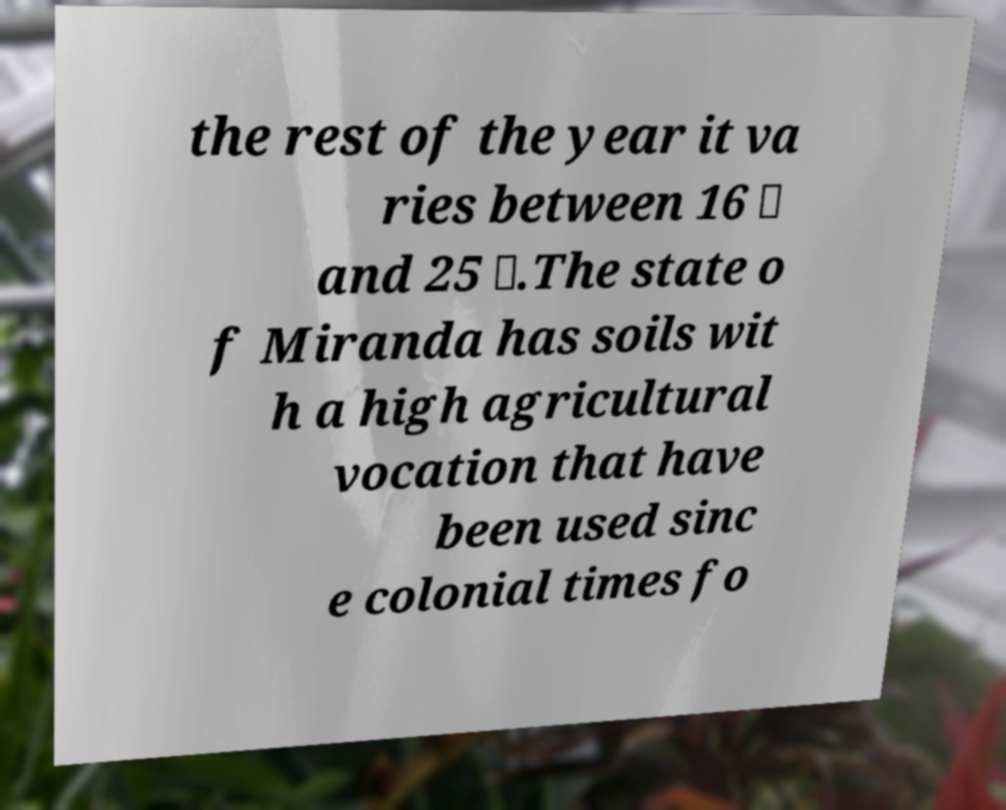Can you read and provide the text displayed in the image?This photo seems to have some interesting text. Can you extract and type it out for me? the rest of the year it va ries between 16 ℃ and 25 ℃.The state o f Miranda has soils wit h a high agricultural vocation that have been used sinc e colonial times fo 